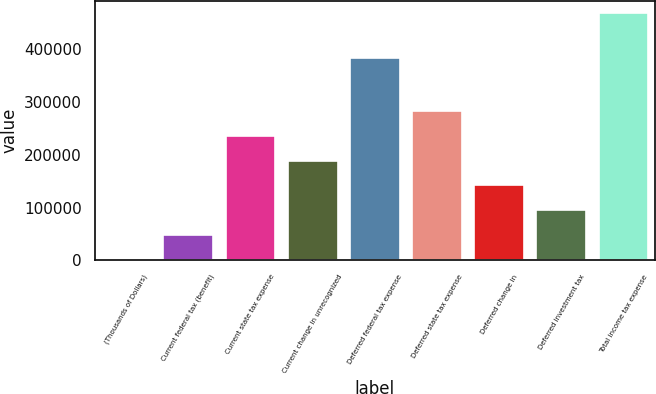<chart> <loc_0><loc_0><loc_500><loc_500><bar_chart><fcel>(Thousands of Dollars)<fcel>Current federal tax (benefit)<fcel>Current state tax expense<fcel>Current change in unrecognized<fcel>Deferred federal tax expense<fcel>Deferred state tax expense<fcel>Deferred change in<fcel>Deferred investment tax<fcel>Total income tax expense<nl><fcel>2011<fcel>48641.5<fcel>235164<fcel>188533<fcel>383931<fcel>281794<fcel>141902<fcel>95272<fcel>468316<nl></chart> 